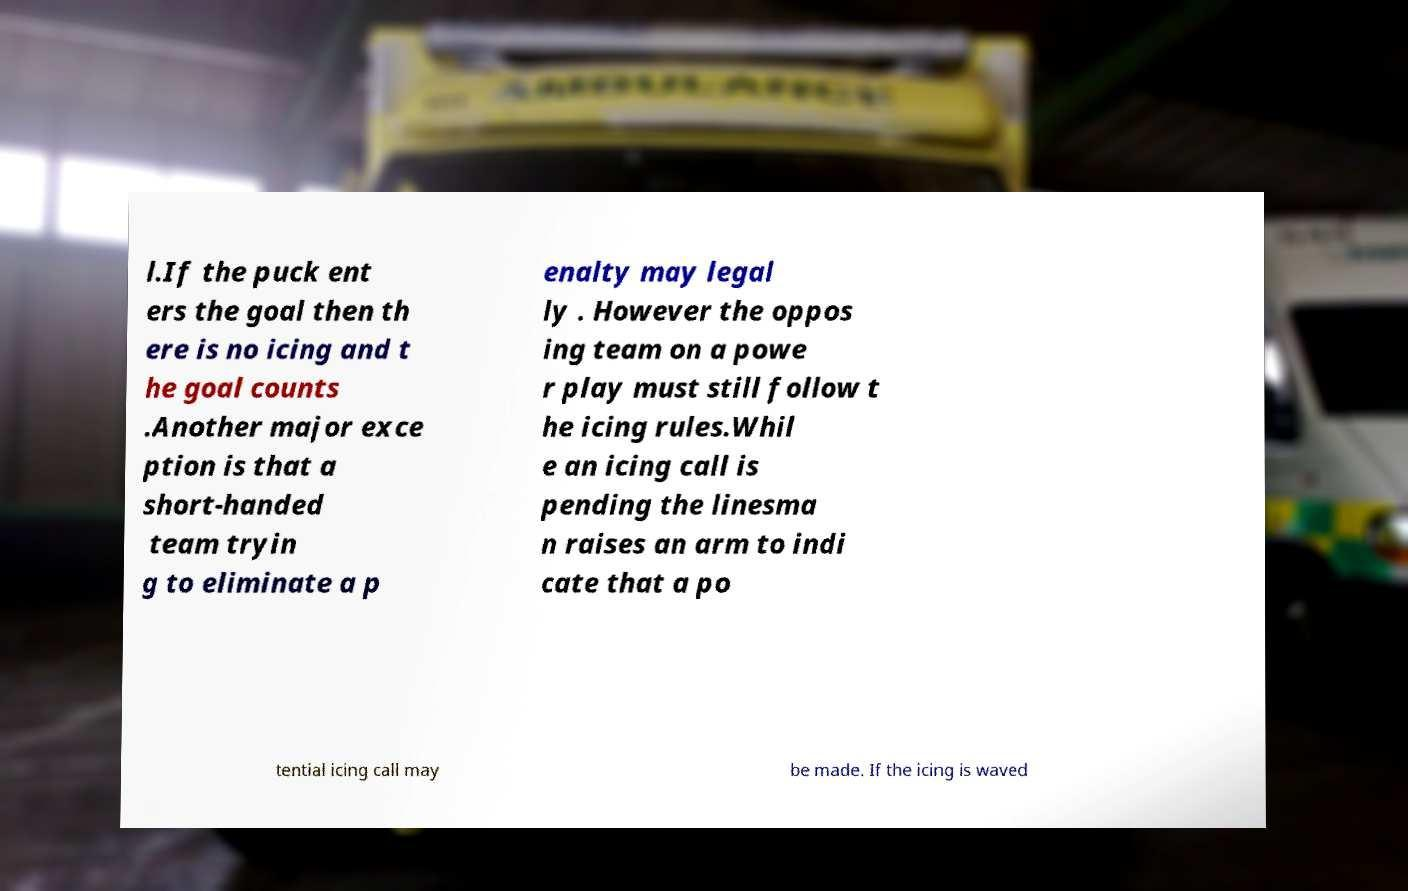I need the written content from this picture converted into text. Can you do that? l.If the puck ent ers the goal then th ere is no icing and t he goal counts .Another major exce ption is that a short-handed team tryin g to eliminate a p enalty may legal ly . However the oppos ing team on a powe r play must still follow t he icing rules.Whil e an icing call is pending the linesma n raises an arm to indi cate that a po tential icing call may be made. If the icing is waved 